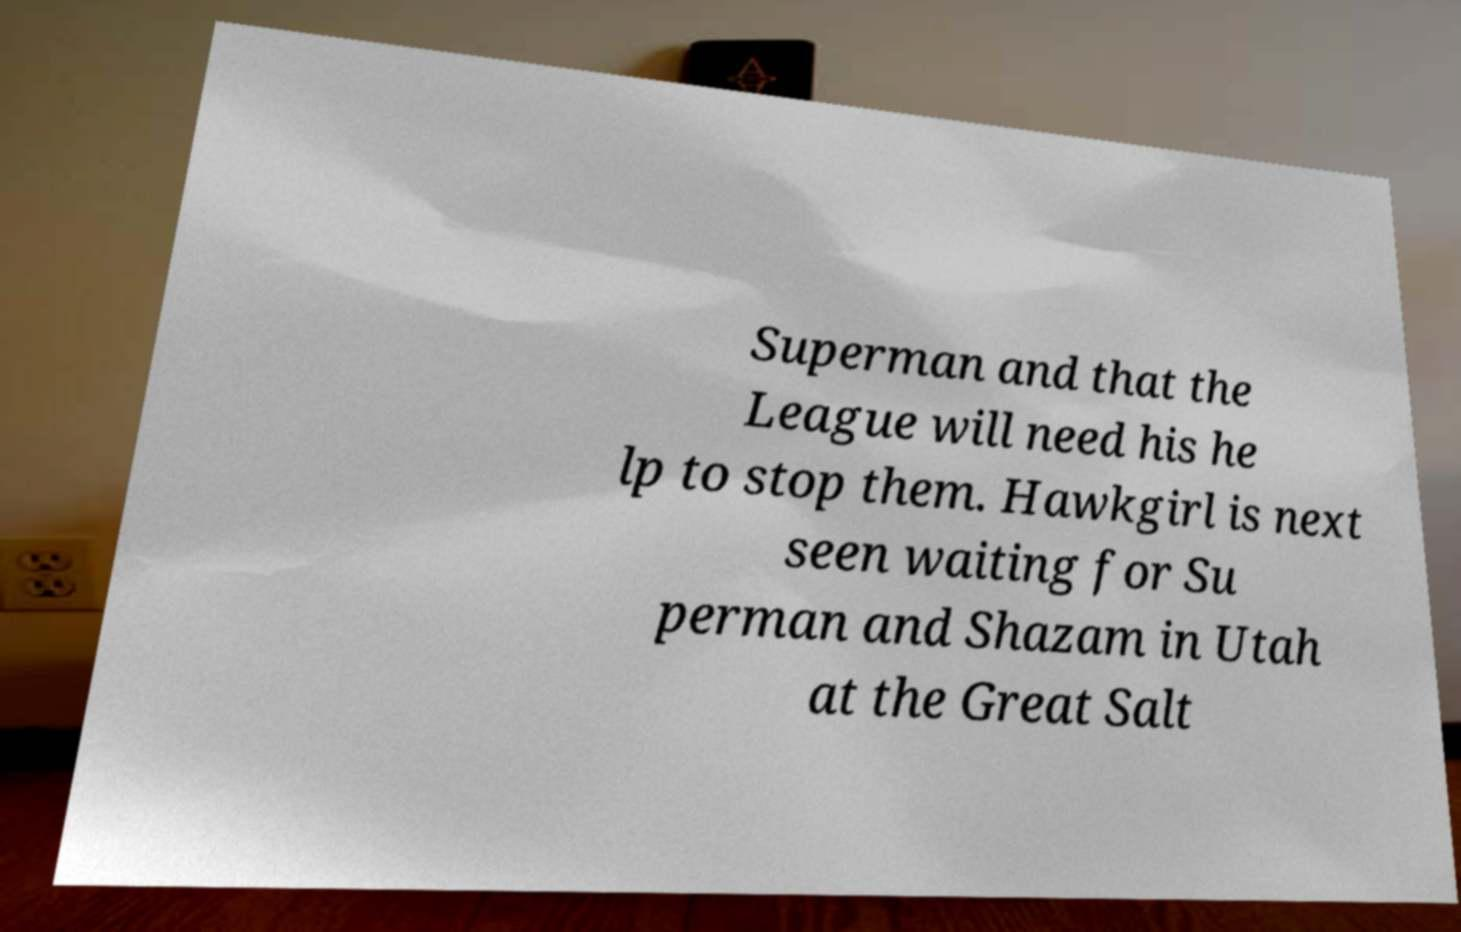Could you assist in decoding the text presented in this image and type it out clearly? Superman and that the League will need his he lp to stop them. Hawkgirl is next seen waiting for Su perman and Shazam in Utah at the Great Salt 